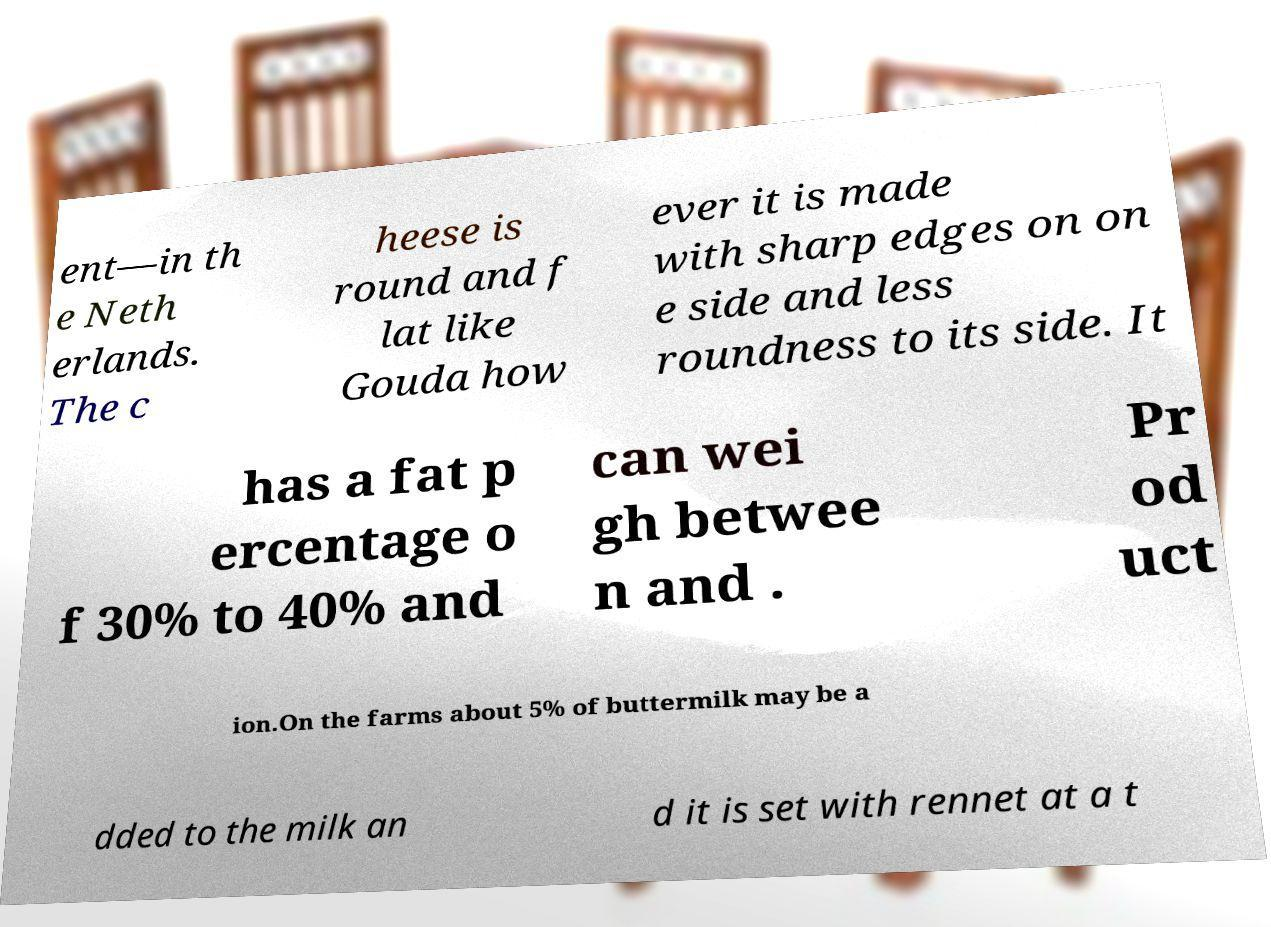Can you accurately transcribe the text from the provided image for me? ent—in th e Neth erlands. The c heese is round and f lat like Gouda how ever it is made with sharp edges on on e side and less roundness to its side. It has a fat p ercentage o f 30% to 40% and can wei gh betwee n and . Pr od uct ion.On the farms about 5% of buttermilk may be a dded to the milk an d it is set with rennet at a t 